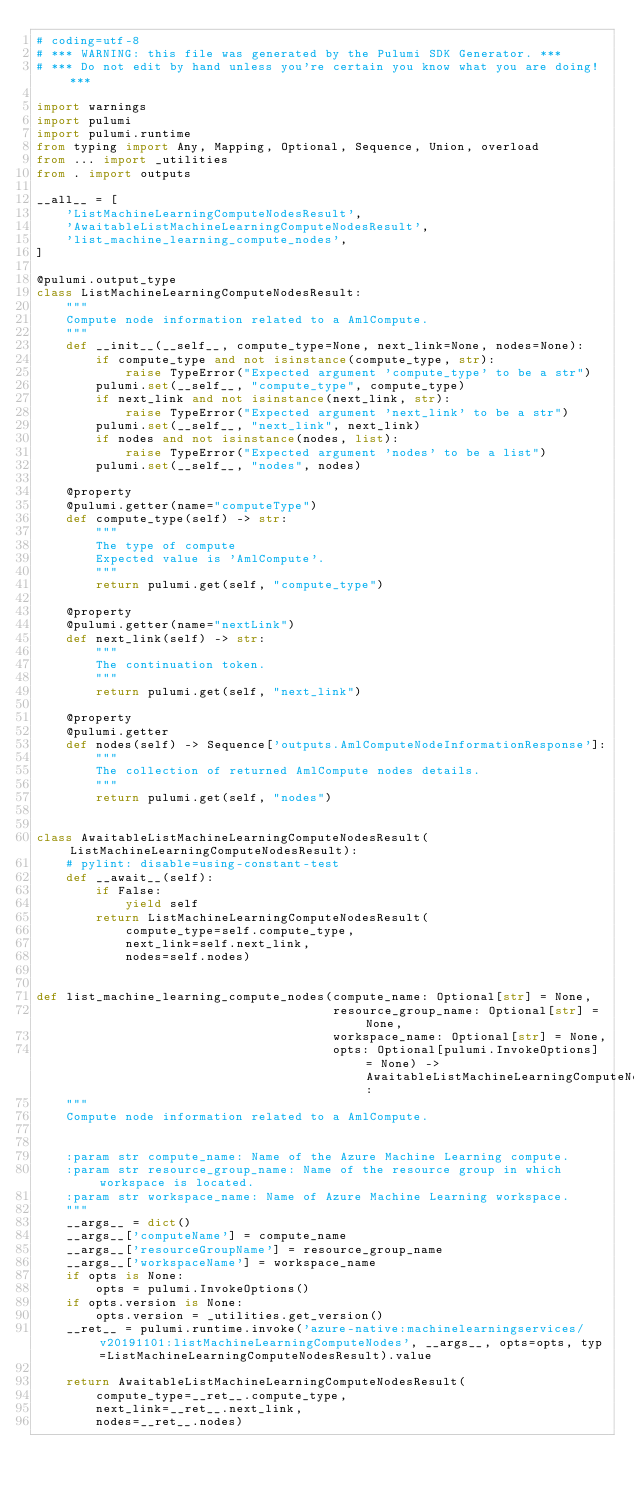<code> <loc_0><loc_0><loc_500><loc_500><_Python_># coding=utf-8
# *** WARNING: this file was generated by the Pulumi SDK Generator. ***
# *** Do not edit by hand unless you're certain you know what you are doing! ***

import warnings
import pulumi
import pulumi.runtime
from typing import Any, Mapping, Optional, Sequence, Union, overload
from ... import _utilities
from . import outputs

__all__ = [
    'ListMachineLearningComputeNodesResult',
    'AwaitableListMachineLearningComputeNodesResult',
    'list_machine_learning_compute_nodes',
]

@pulumi.output_type
class ListMachineLearningComputeNodesResult:
    """
    Compute node information related to a AmlCompute.
    """
    def __init__(__self__, compute_type=None, next_link=None, nodes=None):
        if compute_type and not isinstance(compute_type, str):
            raise TypeError("Expected argument 'compute_type' to be a str")
        pulumi.set(__self__, "compute_type", compute_type)
        if next_link and not isinstance(next_link, str):
            raise TypeError("Expected argument 'next_link' to be a str")
        pulumi.set(__self__, "next_link", next_link)
        if nodes and not isinstance(nodes, list):
            raise TypeError("Expected argument 'nodes' to be a list")
        pulumi.set(__self__, "nodes", nodes)

    @property
    @pulumi.getter(name="computeType")
    def compute_type(self) -> str:
        """
        The type of compute
        Expected value is 'AmlCompute'.
        """
        return pulumi.get(self, "compute_type")

    @property
    @pulumi.getter(name="nextLink")
    def next_link(self) -> str:
        """
        The continuation token.
        """
        return pulumi.get(self, "next_link")

    @property
    @pulumi.getter
    def nodes(self) -> Sequence['outputs.AmlComputeNodeInformationResponse']:
        """
        The collection of returned AmlCompute nodes details.
        """
        return pulumi.get(self, "nodes")


class AwaitableListMachineLearningComputeNodesResult(ListMachineLearningComputeNodesResult):
    # pylint: disable=using-constant-test
    def __await__(self):
        if False:
            yield self
        return ListMachineLearningComputeNodesResult(
            compute_type=self.compute_type,
            next_link=self.next_link,
            nodes=self.nodes)


def list_machine_learning_compute_nodes(compute_name: Optional[str] = None,
                                        resource_group_name: Optional[str] = None,
                                        workspace_name: Optional[str] = None,
                                        opts: Optional[pulumi.InvokeOptions] = None) -> AwaitableListMachineLearningComputeNodesResult:
    """
    Compute node information related to a AmlCompute.


    :param str compute_name: Name of the Azure Machine Learning compute.
    :param str resource_group_name: Name of the resource group in which workspace is located.
    :param str workspace_name: Name of Azure Machine Learning workspace.
    """
    __args__ = dict()
    __args__['computeName'] = compute_name
    __args__['resourceGroupName'] = resource_group_name
    __args__['workspaceName'] = workspace_name
    if opts is None:
        opts = pulumi.InvokeOptions()
    if opts.version is None:
        opts.version = _utilities.get_version()
    __ret__ = pulumi.runtime.invoke('azure-native:machinelearningservices/v20191101:listMachineLearningComputeNodes', __args__, opts=opts, typ=ListMachineLearningComputeNodesResult).value

    return AwaitableListMachineLearningComputeNodesResult(
        compute_type=__ret__.compute_type,
        next_link=__ret__.next_link,
        nodes=__ret__.nodes)
</code> 